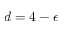Convert formula to latex. <formula><loc_0><loc_0><loc_500><loc_500>d = 4 - \epsilon</formula> 